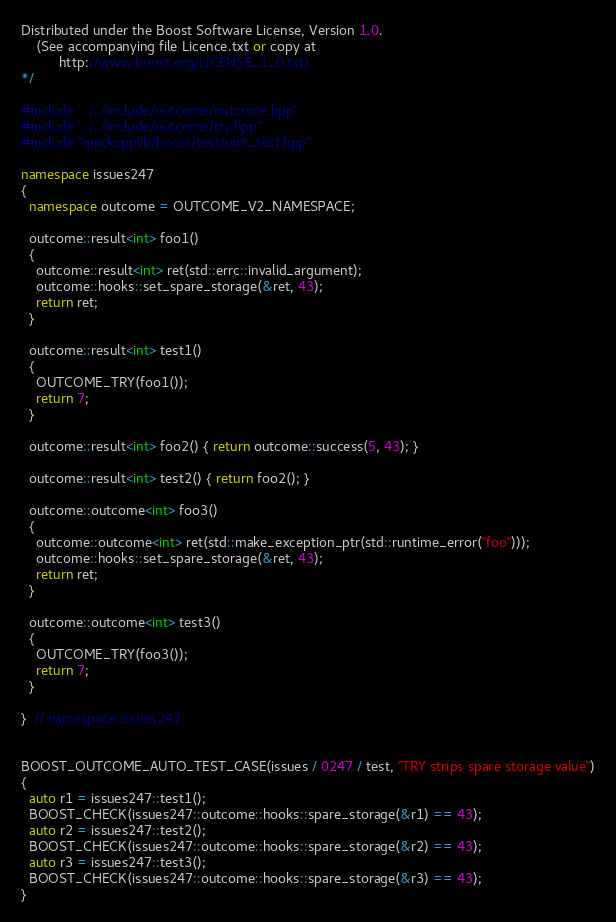<code> <loc_0><loc_0><loc_500><loc_500><_C++_>

Distributed under the Boost Software License, Version 1.0.
    (See accompanying file Licence.txt or copy at
          http://www.boost.org/LICENSE_1_0.txt)
*/

#include "../../include/outcome/outcome.hpp"
#include "../../include/outcome/try.hpp"
#include "quickcpplib/boost/test/unit_test.hpp"

namespace issues247
{
  namespace outcome = OUTCOME_V2_NAMESPACE;

  outcome::result<int> foo1()
  {
    outcome::result<int> ret(std::errc::invalid_argument);
    outcome::hooks::set_spare_storage(&ret, 43);
    return ret;
  }

  outcome::result<int> test1()
  {
    OUTCOME_TRY(foo1());
    return 7;
  }

  outcome::result<int> foo2() { return outcome::success(5, 43); }

  outcome::result<int> test2() { return foo2(); }

  outcome::outcome<int> foo3()
  {
    outcome::outcome<int> ret(std::make_exception_ptr(std::runtime_error("foo")));
    outcome::hooks::set_spare_storage(&ret, 43);
    return ret;
  }

  outcome::outcome<int> test3()
  {
    OUTCOME_TRY(foo3());
    return 7;
  }

}  // namespace issues247


BOOST_OUTCOME_AUTO_TEST_CASE(issues / 0247 / test, "TRY strips spare storage value")
{
  auto r1 = issues247::test1();
  BOOST_CHECK(issues247::outcome::hooks::spare_storage(&r1) == 43);
  auto r2 = issues247::test2();
  BOOST_CHECK(issues247::outcome::hooks::spare_storage(&r2) == 43);
  auto r3 = issues247::test3();
  BOOST_CHECK(issues247::outcome::hooks::spare_storage(&r3) == 43);
}
</code> 